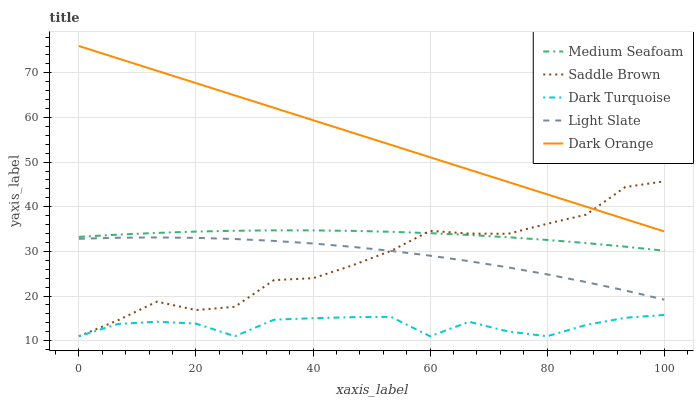Does Dark Turquoise have the minimum area under the curve?
Answer yes or no. Yes. Does Dark Orange have the maximum area under the curve?
Answer yes or no. Yes. Does Medium Seafoam have the minimum area under the curve?
Answer yes or no. No. Does Medium Seafoam have the maximum area under the curve?
Answer yes or no. No. Is Dark Orange the smoothest?
Answer yes or no. Yes. Is Saddle Brown the roughest?
Answer yes or no. Yes. Is Dark Turquoise the smoothest?
Answer yes or no. No. Is Dark Turquoise the roughest?
Answer yes or no. No. Does Medium Seafoam have the lowest value?
Answer yes or no. No. Does Dark Orange have the highest value?
Answer yes or no. Yes. Does Medium Seafoam have the highest value?
Answer yes or no. No. Is Light Slate less than Dark Orange?
Answer yes or no. Yes. Is Light Slate greater than Dark Turquoise?
Answer yes or no. Yes. Does Medium Seafoam intersect Saddle Brown?
Answer yes or no. Yes. Is Medium Seafoam less than Saddle Brown?
Answer yes or no. No. Is Medium Seafoam greater than Saddle Brown?
Answer yes or no. No. Does Light Slate intersect Dark Orange?
Answer yes or no. No. 